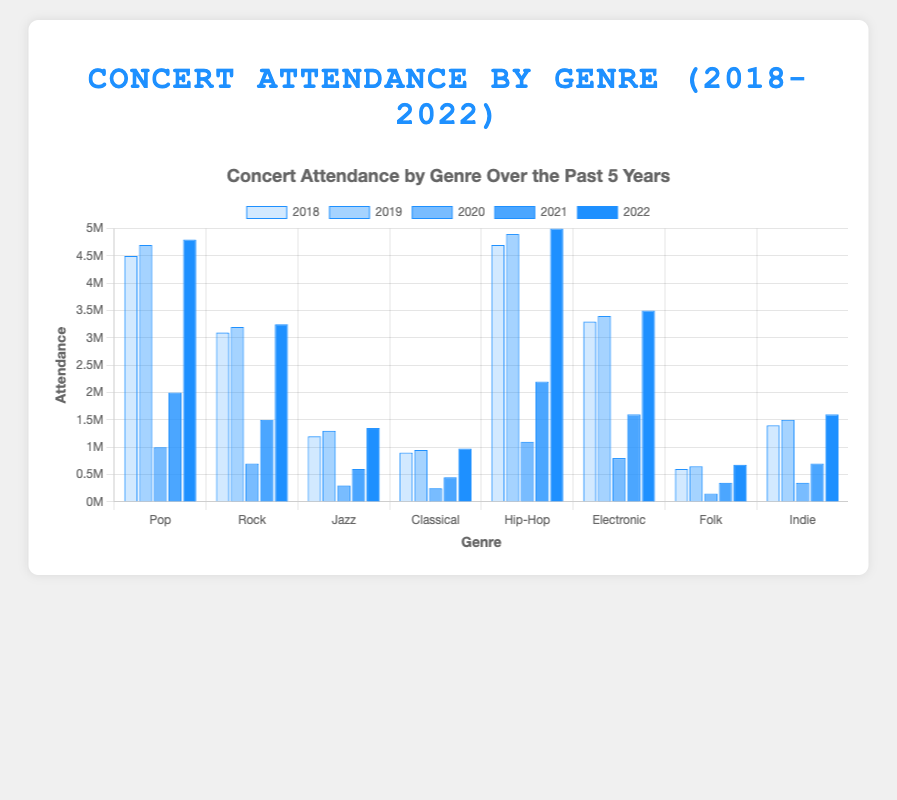How did concert attendance for the Pop genre change from 2020 to 2022? In 2020, Pop attendance was 1,000,000. In 2021, it increased to 2,000,000, and in 2022, it surged to 4,800,000. Therefore, the increase from 2020 to 2022 is 4,800,000 - 1,000,000 = 3,800,000.
Answer: 3,800,000 Which genre had the highest concert attendance in 2022? In 2022, the Hip-Hop genre had the highest concert attendance with 5,000,000 attendees.
Answer: Hip-Hop What was the combined attendance for Folk and Indie genres in 2019? In 2019, Folk had 650,000 attendees and Indie had 1,500,000 attendees. The combined attendance is 650,000 + 1,500,000 = 2,150,000.
Answer: 2,150,000 How does the attendance of Jazz in 2020 compare to Jazz in 2021? Jazz attendance was 300,000 in 2020 and increased to 600,000 in 2021. The increase is 600,000 - 300,000 = 300,000, so the attendance doubled.
Answer: It doubled Which year had the lowest overall concert attendance? Looking at the overall attendance for all genres across the years, 2020 had the lowest due to significant drops, likely due to external factors like the pandemic.
Answer: 2020 What is the average attendance for the Rock genre over the 5 years? Summing up Rock attendances: 3,100,000 (2018) + 3,200,000 (2019) + 700,000 (2020) + 1,500,000 (2021) + 3,250,000 (2022) = 11,750,000. Divide this by 5 years: 11,750,000 / 5 = 2,350,000.
Answer: 2,350,000 How much did the attendance for Electronic music increase or decrease from 2019 to 2021? In 2019, Electronic attendance was 3,400,000 and in 2021, it was 1,600,000. The decrease is 3,400,000 - 1,600,000 = 1,800,000.
Answer: Decrease of 1,800,000 What visual trend do you notice for concert attendance across all genres in 2020? In 2020, there is a visible sharp decline in attendance across all genres, likely due to the global pandemic impact.
Answer: Sharp decline Which genre consistently had the second highest attendance from 2018 to 2022? The Pop genre consistently had the second highest attendance each year except in 2022 when it was surpassed by Hip-Hop.
Answer: Pop By how much did Classical concert attendance grow from 2019 to 2022? Classical attendance increased from 950,000 in 2019 to 975,000 in 2022. The growth is 975,000 - 950,000 = 25,000.
Answer: 25,000 